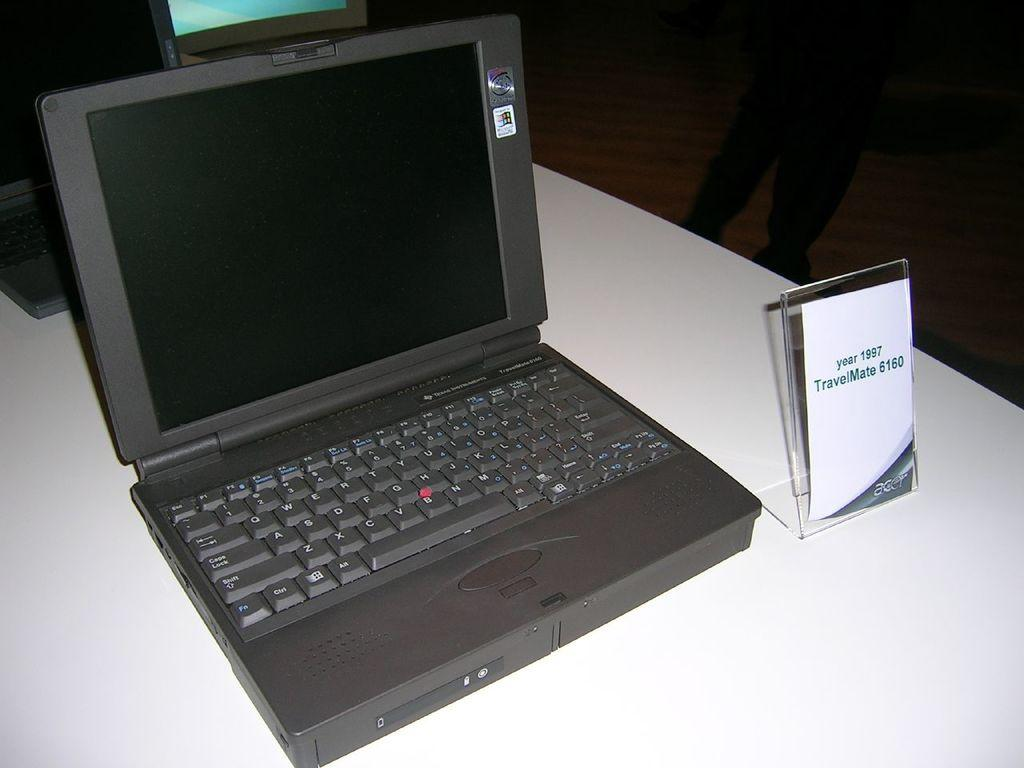<image>
Offer a succinct explanation of the picture presented. A sign next to a laptop says that this is the TravelMate 6160 fro 1997. 